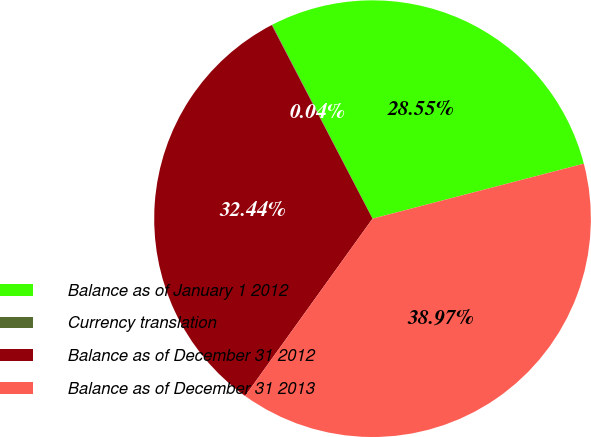Convert chart to OTSL. <chart><loc_0><loc_0><loc_500><loc_500><pie_chart><fcel>Balance as of January 1 2012<fcel>Currency translation<fcel>Balance as of December 31 2012<fcel>Balance as of December 31 2013<nl><fcel>28.55%<fcel>0.04%<fcel>32.44%<fcel>38.97%<nl></chart> 